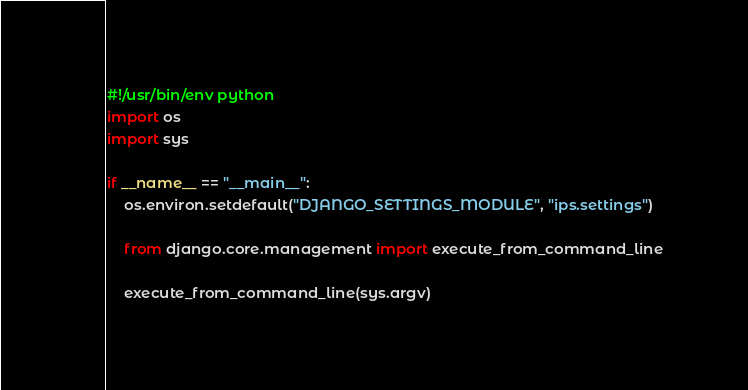Convert code to text. <code><loc_0><loc_0><loc_500><loc_500><_Python_>#!/usr/bin/env python
import os
import sys

if __name__ == "__main__":
    os.environ.setdefault("DJANGO_SETTINGS_MODULE", "ips.settings")

    from django.core.management import execute_from_command_line

    execute_from_command_line(sys.argv)
</code> 